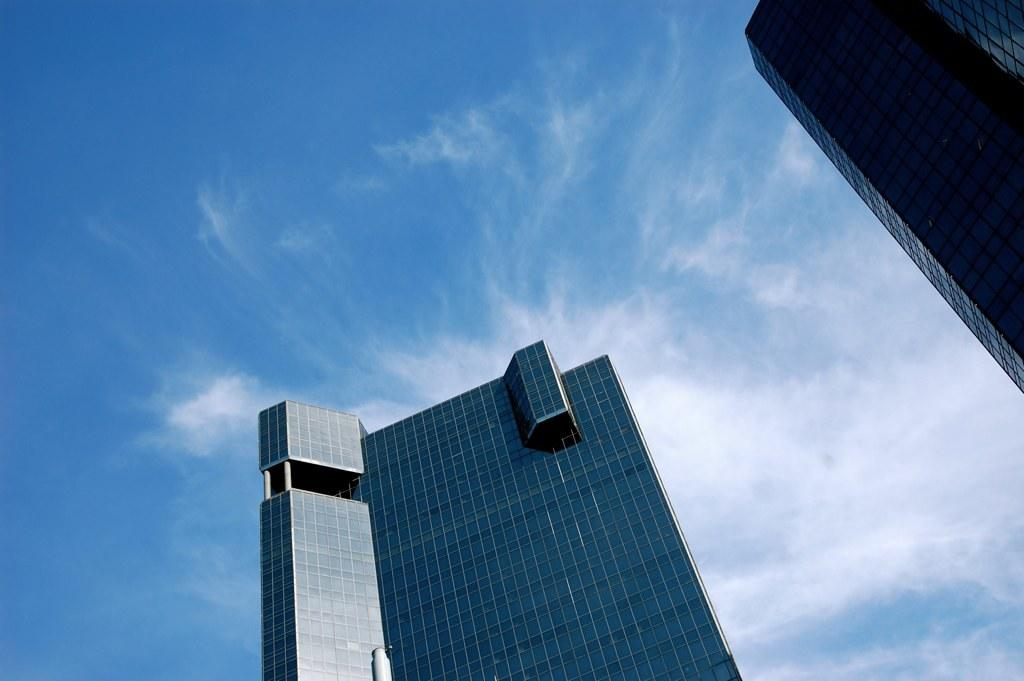What type of building is located in the foreground of the image? There is a glass building in the foreground of the image. Where is the glass building situated in the image? The glass building is on the right top corner of the image. Can you describe the background of the image? There is another glass building in the background of the image, and the sky is visible. What can be seen in the sky? Clouds are present in the sky. What type of animal can be seen climbing the glass building in the image? There are no animals present in the image, and no animals are climbing the glass building. 